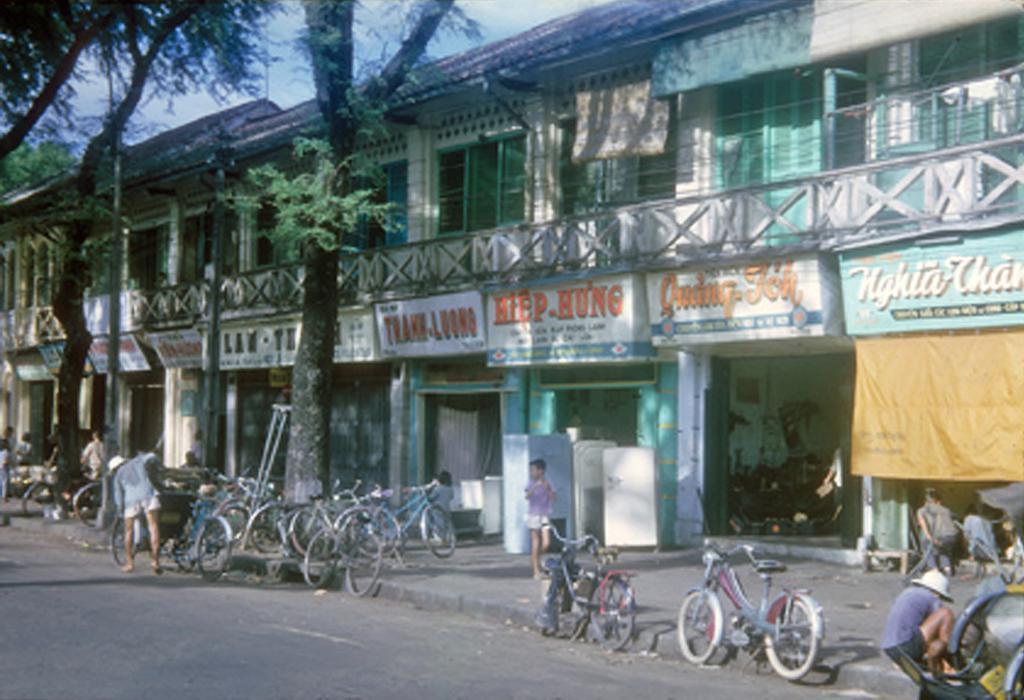Describe this image in one or two sentences. In the image there are a lot of stores and in front of the stores there are cycles, trees, people and road. 